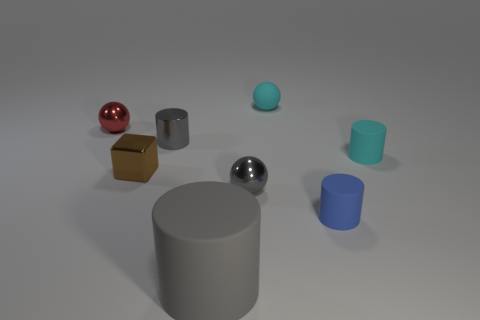Add 1 tiny balls. How many objects exist? 9 Subtract all cubes. How many objects are left? 7 Subtract all brown metal objects. Subtract all small gray matte cylinders. How many objects are left? 7 Add 7 cubes. How many cubes are left? 8 Add 5 small blue matte cylinders. How many small blue matte cylinders exist? 6 Subtract 0 gray cubes. How many objects are left? 8 